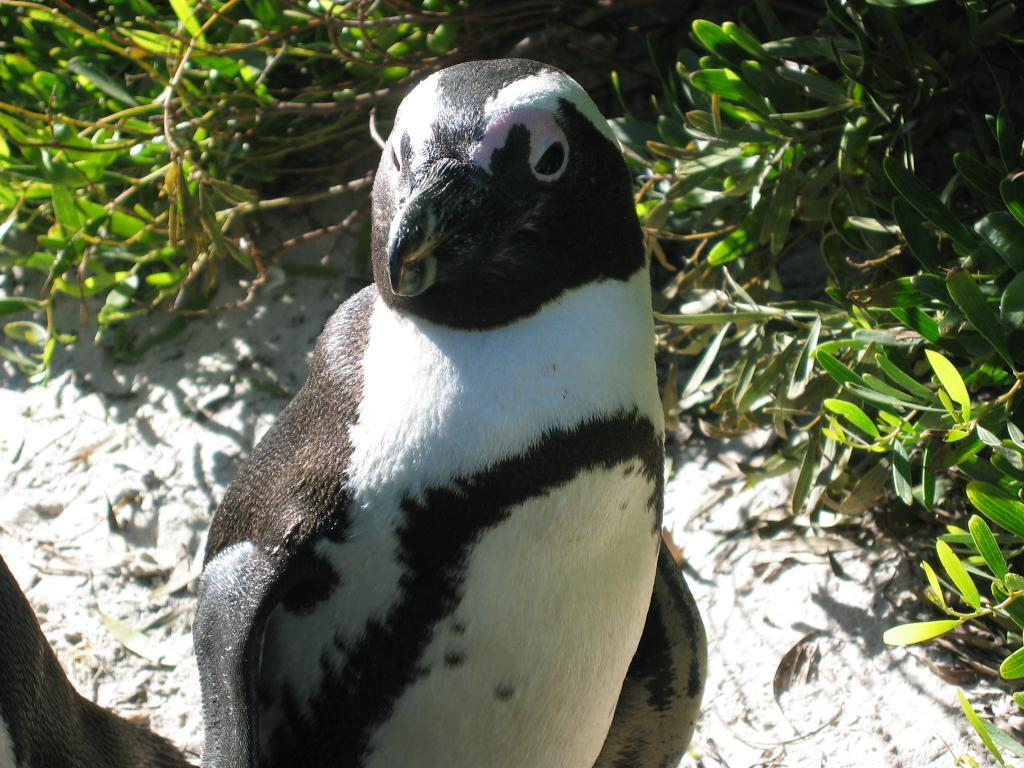What type of animal is in the image? There is a penguin in the image. What can be seen in the background of the image? There are plants in the background of the image. What is at the bottom of the image? There is sand at the bottom of the image. What type of leaf is being used as a flag in the image? There is no leaf or flag present in the image; it features a penguin, plants, and sand. Can you tell me how many birds are flying in the image? There is only one bird-like animal present in the image, which is the penguin, and it is not flying. 